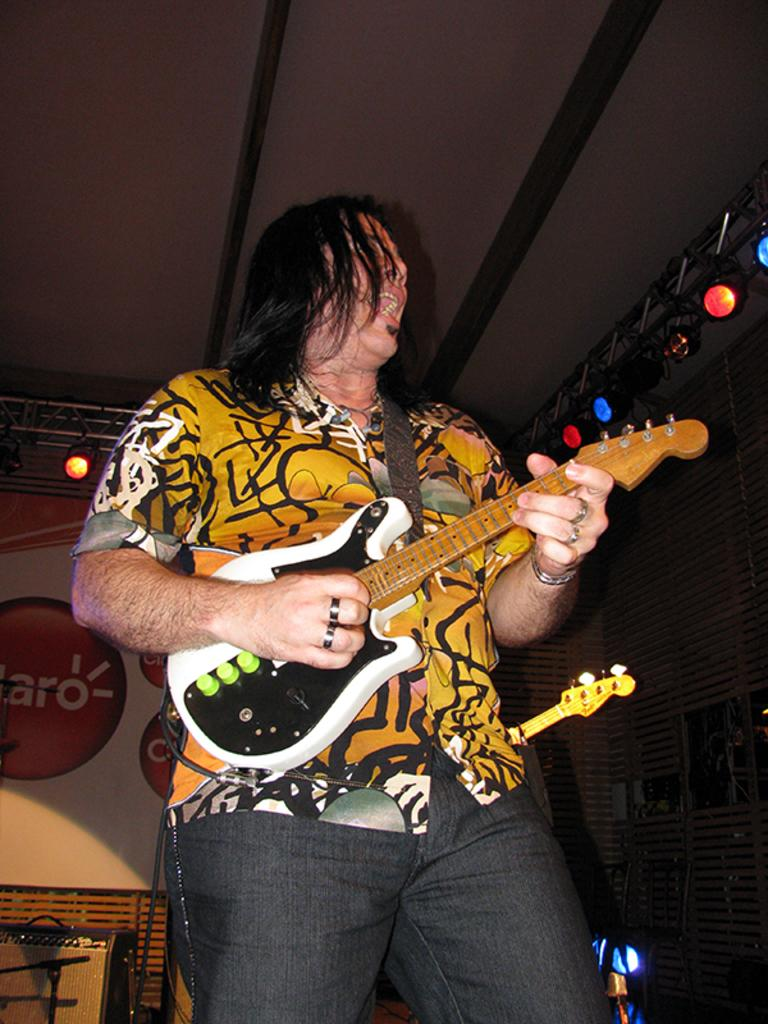What is the man in the image doing? The man is playing the guitar and singing. Can you describe the lighting in the image? There are lights on the right side of the image. What can be seen on the wall in the background of the image? There is a painting on the wall in the background of the image. Can you see any clouds in the image? There are no clouds visible in the image. How does the man turn the knot while playing the guitar? There is no knot present in the image, and the man is not turning anything while playing the guitar. 